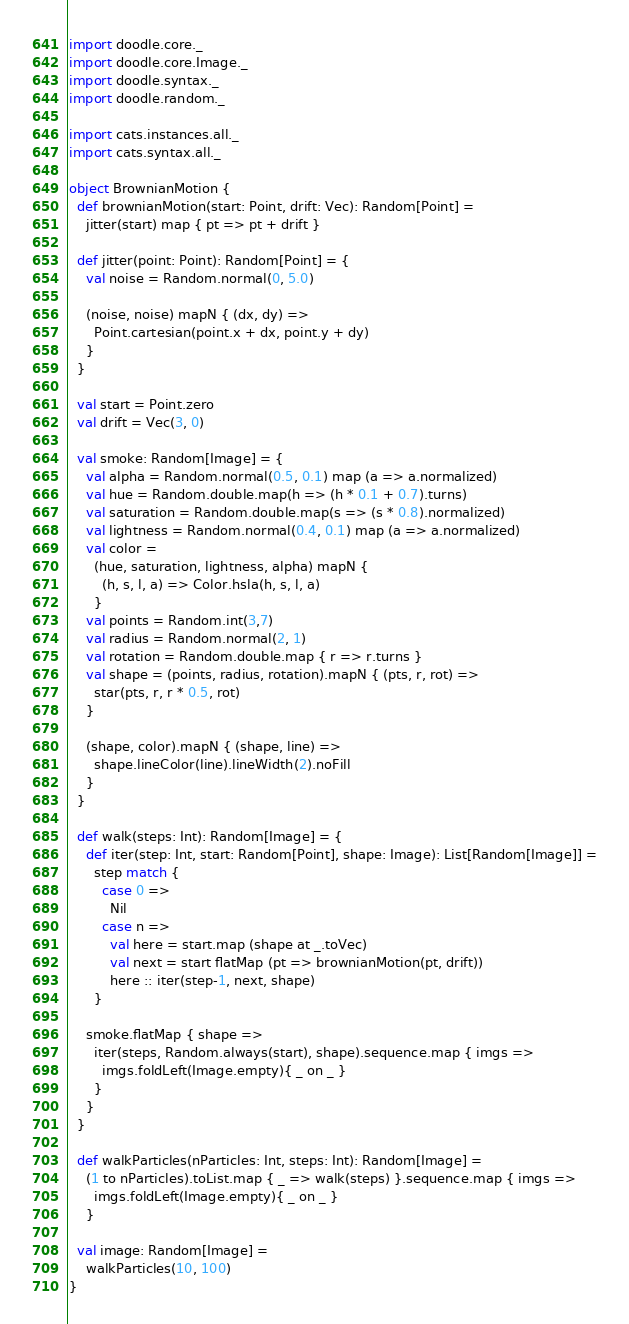Convert code to text. <code><loc_0><loc_0><loc_500><loc_500><_Scala_>
import doodle.core._
import doodle.core.Image._
import doodle.syntax._
import doodle.random._

import cats.instances.all._
import cats.syntax.all._

object BrownianMotion {
  def brownianMotion(start: Point, drift: Vec): Random[Point] =
    jitter(start) map { pt => pt + drift }

  def jitter(point: Point): Random[Point] = {
    val noise = Random.normal(0, 5.0)

    (noise, noise) mapN { (dx, dy) =>
      Point.cartesian(point.x + dx, point.y + dy)
    }
  }

  val start = Point.zero
  val drift = Vec(3, 0)

  val smoke: Random[Image] = {
    val alpha = Random.normal(0.5, 0.1) map (a => a.normalized)
    val hue = Random.double.map(h => (h * 0.1 + 0.7).turns)
    val saturation = Random.double.map(s => (s * 0.8).normalized)
    val lightness = Random.normal(0.4, 0.1) map (a => a.normalized)
    val color =
      (hue, saturation, lightness, alpha) mapN {
        (h, s, l, a) => Color.hsla(h, s, l, a)
      }
    val points = Random.int(3,7)
    val radius = Random.normal(2, 1)
    val rotation = Random.double.map { r => r.turns }
    val shape = (points, radius, rotation).mapN { (pts, r, rot) =>
      star(pts, r, r * 0.5, rot)
    }

    (shape, color).mapN { (shape, line) =>
      shape.lineColor(line).lineWidth(2).noFill
    }
  }

  def walk(steps: Int): Random[Image] = {
    def iter(step: Int, start: Random[Point], shape: Image): List[Random[Image]] =
      step match {
        case 0 =>
          Nil
        case n =>
          val here = start.map (shape at _.toVec)
          val next = start flatMap (pt => brownianMotion(pt, drift))
          here :: iter(step-1, next, shape)
      }

    smoke.flatMap { shape =>
      iter(steps, Random.always(start), shape).sequence.map { imgs =>
        imgs.foldLeft(Image.empty){ _ on _ }
      }
    }
  }

  def walkParticles(nParticles: Int, steps: Int): Random[Image] =
    (1 to nParticles).toList.map { _ => walk(steps) }.sequence.map { imgs =>
      imgs.foldLeft(Image.empty){ _ on _ }
    }

  val image: Random[Image] =
    walkParticles(10, 100)
}

</code> 